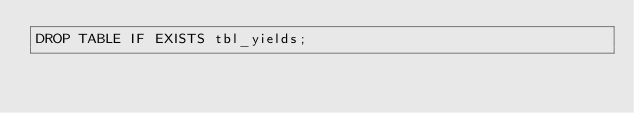<code> <loc_0><loc_0><loc_500><loc_500><_SQL_>DROP TABLE IF EXISTS tbl_yields;</code> 